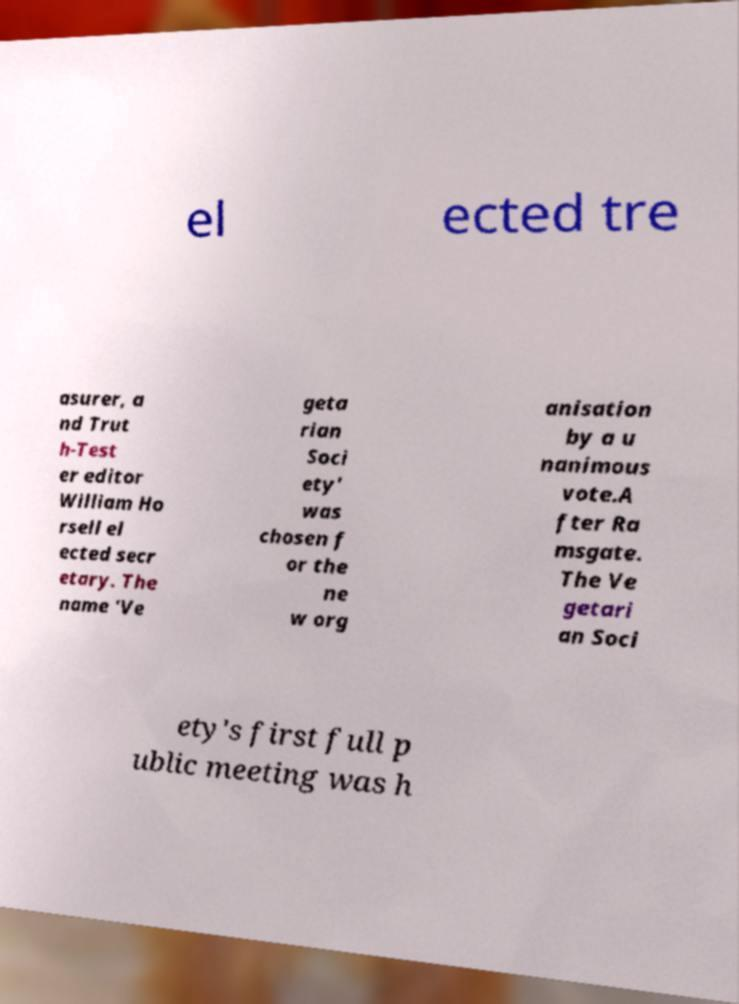Please read and relay the text visible in this image. What does it say? el ected tre asurer, a nd Trut h-Test er editor William Ho rsell el ected secr etary. The name 'Ve geta rian Soci ety' was chosen f or the ne w org anisation by a u nanimous vote.A fter Ra msgate. The Ve getari an Soci ety's first full p ublic meeting was h 